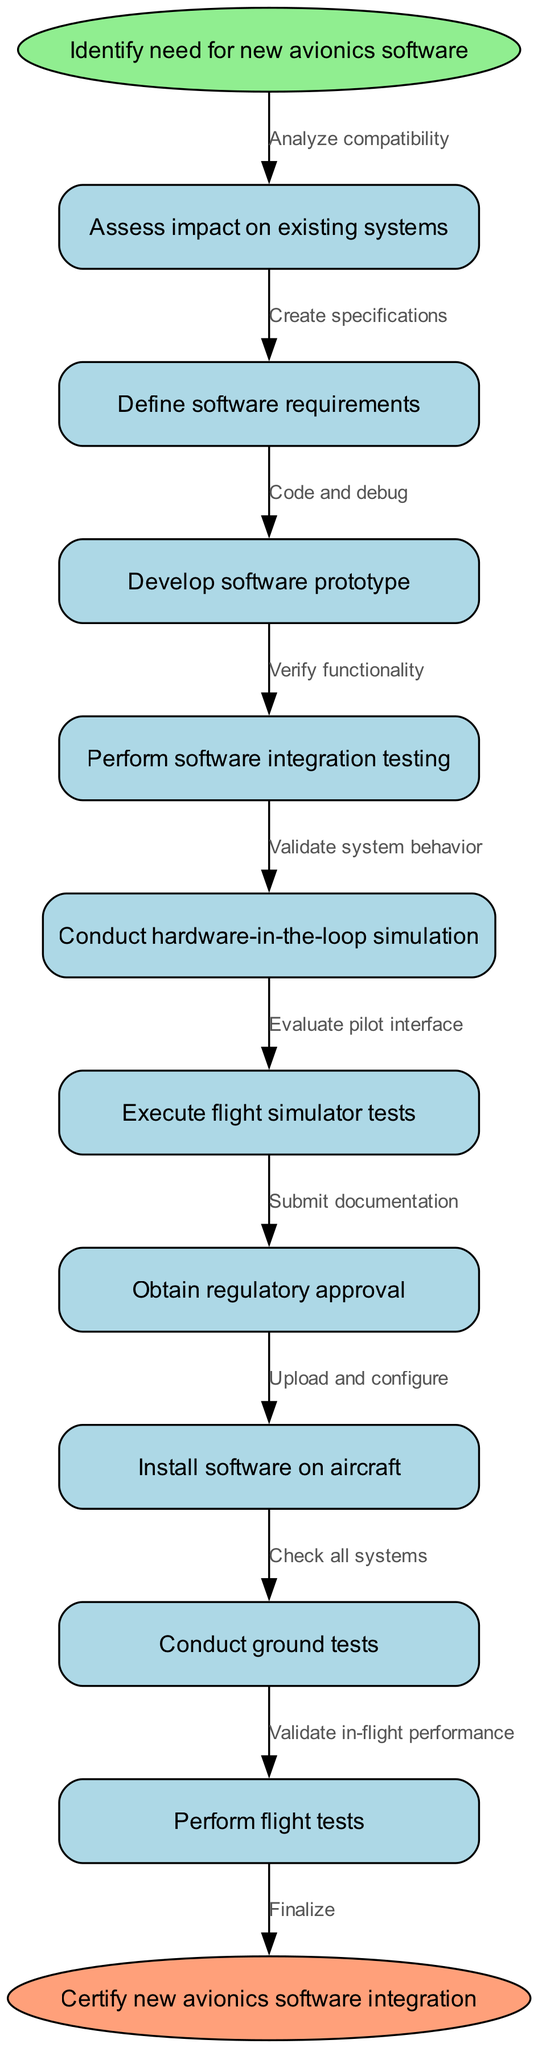What is the start node of the process? The start node is clearly labeled in the diagram as "Identify need for new avionics software." This is the first step in the integration process.
Answer: Identify need for new avionics software How many process nodes are in the diagram? By counting all the nodes listed in the diagram, we see there are ten process nodes that represent different steps in the avionics software integration process.
Answer: 10 What is the last node before the end node? The last process node before reaching the end node in the diagram is "Perform flight tests." This is the final step listed before the certification phase.
Answer: Perform flight tests Which edge connects "Define software requirements" to its preceding node? The edge connecting "Define software requirements" indicates the action taken from the preceding node "Assess impact on existing systems," showing the flow of the process. The specific edge label is "Create specifications."
Answer: Create specifications What edge follows "Execute flight simulator tests"? To find the edge that follows "Execute flight simulator tests," we look at how the flow resumes from that node to the next one. The product of this edge is labeled "Validate in-flight performance."
Answer: Validate in-flight performance What is the final action of the process? The final action is displayed in the end node labeled "Certify new avionics software integration." This signifies the completion of the entire integration process.
Answer: Certify new avionics software integration What step comes after "Conduct hardware-in-the-loop simulation"? To identify the next step, we look at how the nodes are connected. The step that follows "Conduct hardware-in-the-loop simulation" is "Execute flight simulator tests."
Answer: Execute flight simulator tests What action precedes "Upload and configure"? The action that precedes "Upload and configure" can be traced back in the diagram to the node "Install software on aircraft." This shows the sequential nature of the steps.
Answer: Install software on aircraft How does "Analyze compatibility" relate to the start node? "Analyze compatibility" is directly connected to the start node "Identify need for new avionics software." This indicates it is the first action taken after recognizing the need for new software.
Answer: Analyze compatibility 